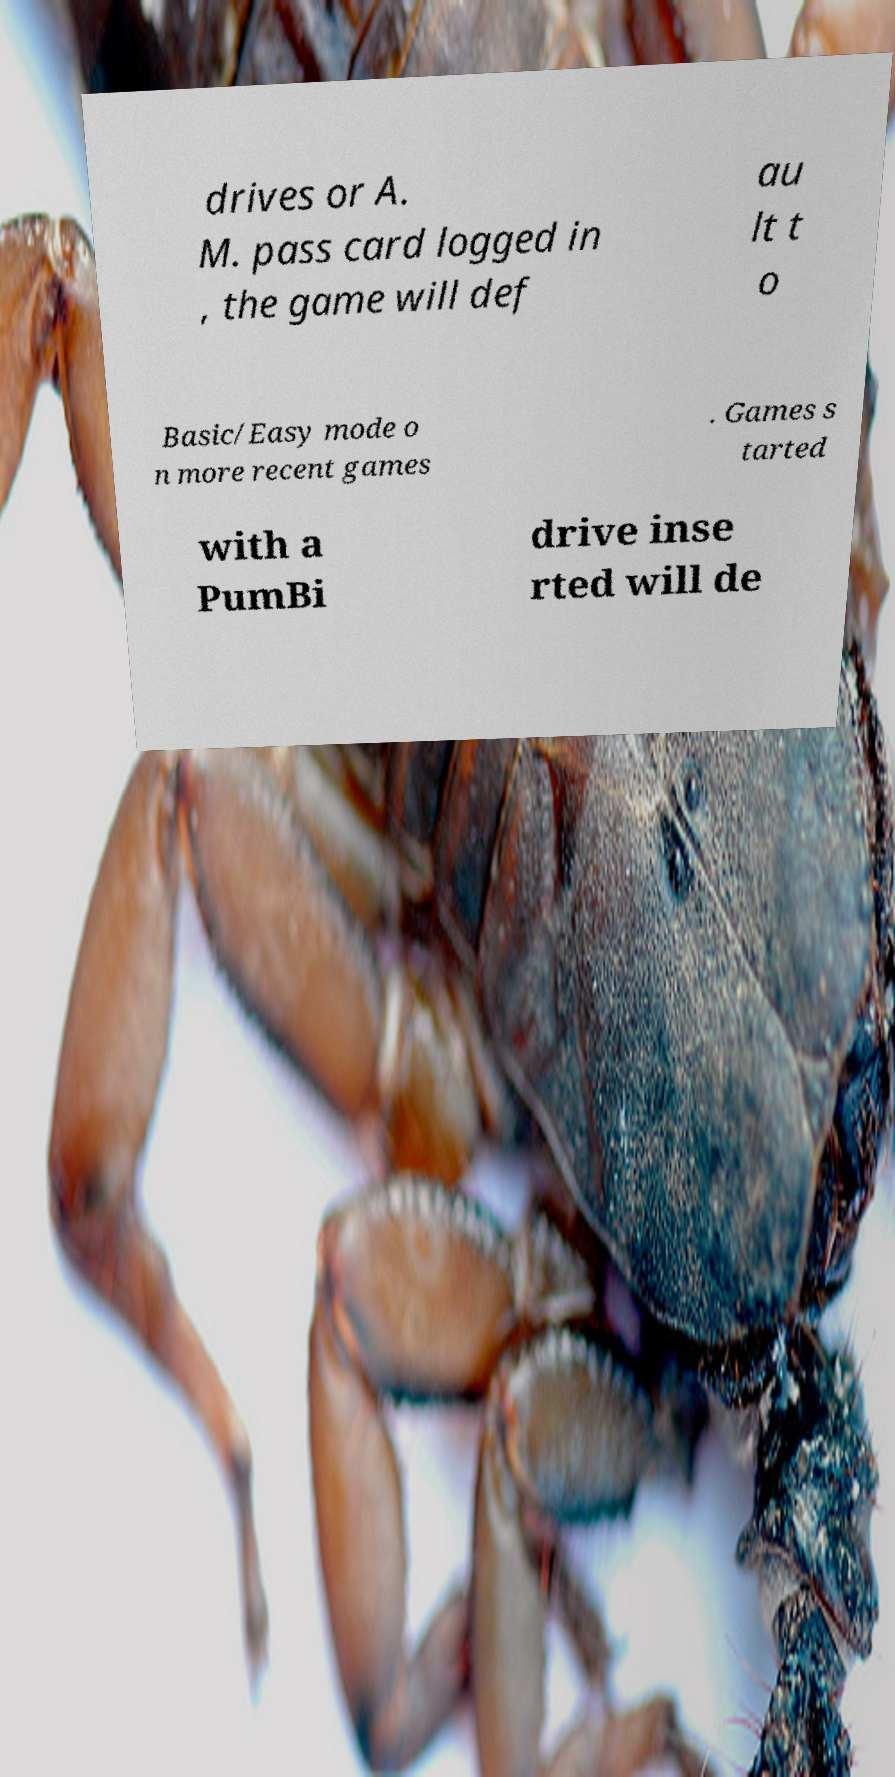For documentation purposes, I need the text within this image transcribed. Could you provide that? drives or A. M. pass card logged in , the game will def au lt t o Basic/Easy mode o n more recent games . Games s tarted with a PumBi drive inse rted will de 